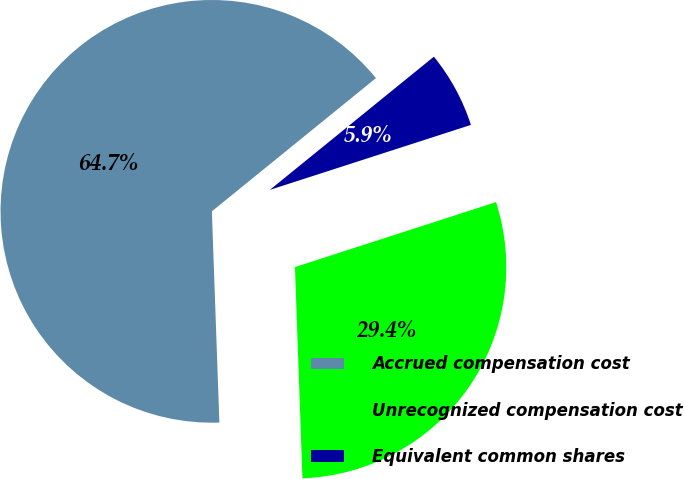Convert chart. <chart><loc_0><loc_0><loc_500><loc_500><pie_chart><fcel>Accrued compensation cost<fcel>Unrecognized compensation cost<fcel>Equivalent common shares<nl><fcel>64.71%<fcel>29.41%<fcel>5.88%<nl></chart> 